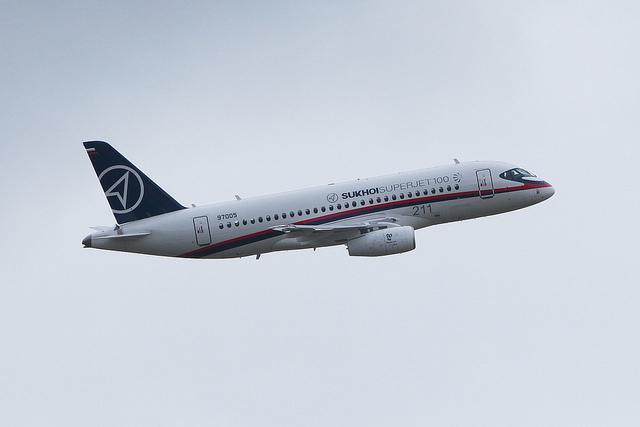How many engines are seen?
Give a very brief answer. 1. How many airplanes can you see?
Give a very brief answer. 1. How many people are holding bats?
Give a very brief answer. 0. 